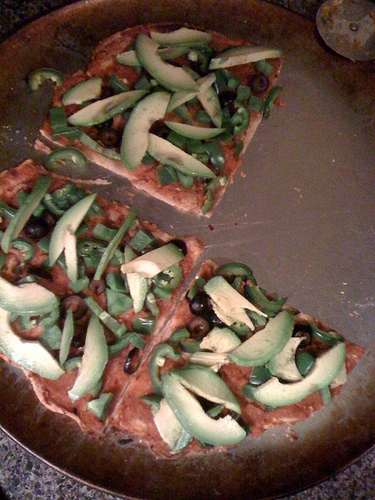Describe the objects in this image and their specific colors. I can see pizza in black, brown, maroon, and gray tones, pizza in black, maroon, gray, and brown tones, and pizza in black, maroon, darkgreen, and gray tones in this image. 